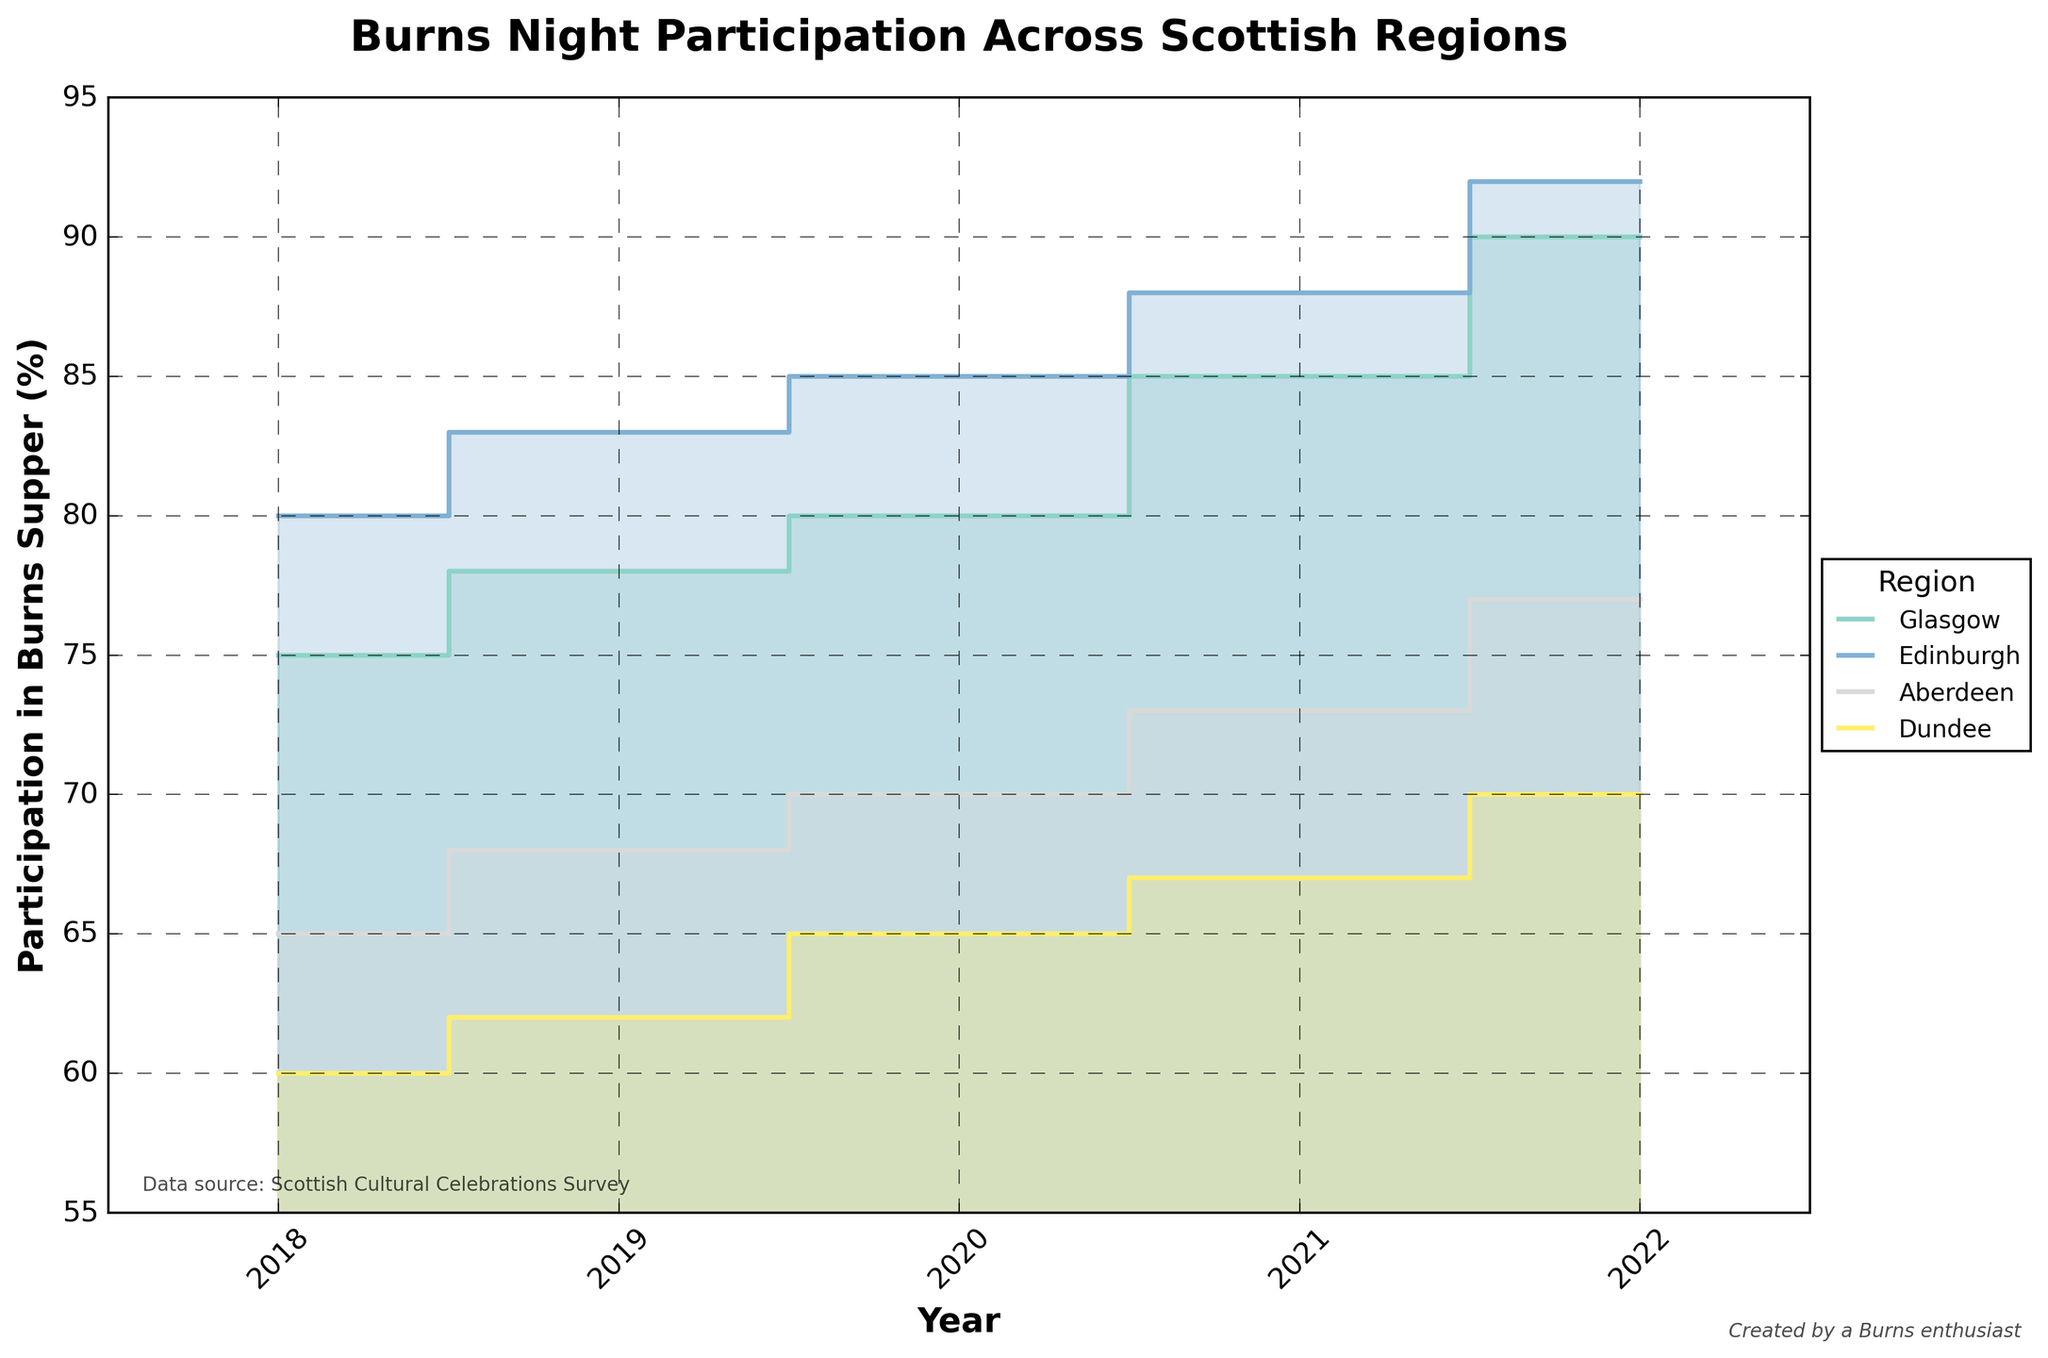how many regions are represented in the chart? Identifying the unique number of regions present in the figure will help answer this question. In the visual, each region’s data is represented by separate areas and different colors. Look at the legend which lists the regions included in the chart.
Answer: 4 Which region showed the highest participation in Burns Supper in 2022? To find this, locate the year 2022 along the x-axis and then look at the height of the step lines for each region. The tallest line represents the highest participation.
Answer: Edinburgh What is the trend in Burns Supper participation in Glasgow from 2018 to 2022? For identifying the trend, check the progression of the step line for Glasgow over the years from 2018 to 2022. Observe if it increases, decreases, or remains constant.
Answer: Increasing Which two regions had the closest Burns Supper participation levels in 2020? Locate the year 2020 on the x-axis, then compare the height of the step lines for each region. Look for the two regions whose lines are the closest to each other in height.
Answer: Glasgow and Edinburgh By how many percent points did Burns Supper participation in Dundee increase between 2018 and 2022? Check Dundee’s participation level in 2018 and 2022. Subtract the 2018 value from the 2022 value to get the difference in percentage points.
Answer: 10% Between which consecutive years did Aberdeen see the largest increase in Burns Supper participation? Track the step line for Aberdeen and assess the vertical jumps from one year to the next. Identify where the increase is the largest.
Answer: 2021-2022 On average, what was the participation in Burns Supper for Edinburgh from 2018 to 2022? Find the participation percentages for Edinburgh for each year, sum them up, and then divide by the number of years (5).
Answer: 85.6% Which regions had their highest Burns Supper participation in 2022? Check the step lines for the year 2022 and see which regions are at their peak point in that year.
Answer: All regions (Glasgow, Edinburgh, Aberdeen, Dundee) How did the participation trend for Aberdeen compare with Dundee from 2018 to 2022? Compare the progression of the step lines for both regions over the years. Note if both increase, decrease, or remain stable, and their respective rates of change.
Answer: Both increased, with Aberdeen having a steeper rise 